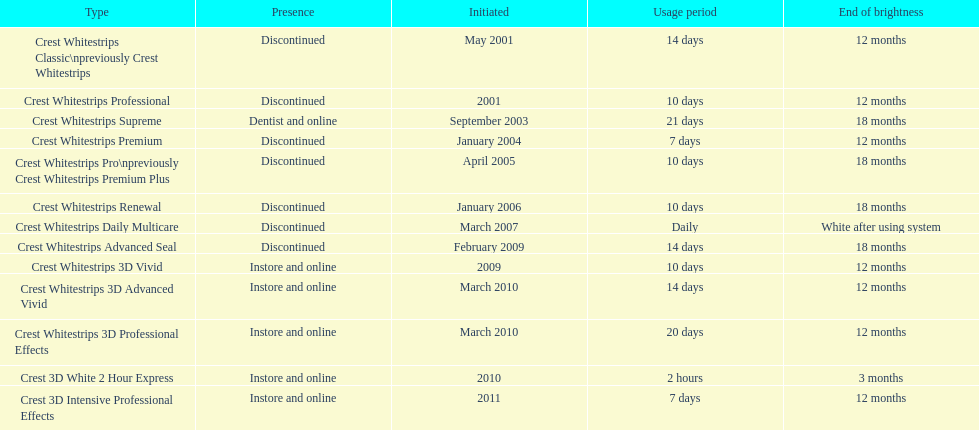How many products have been discontinued? 7. 